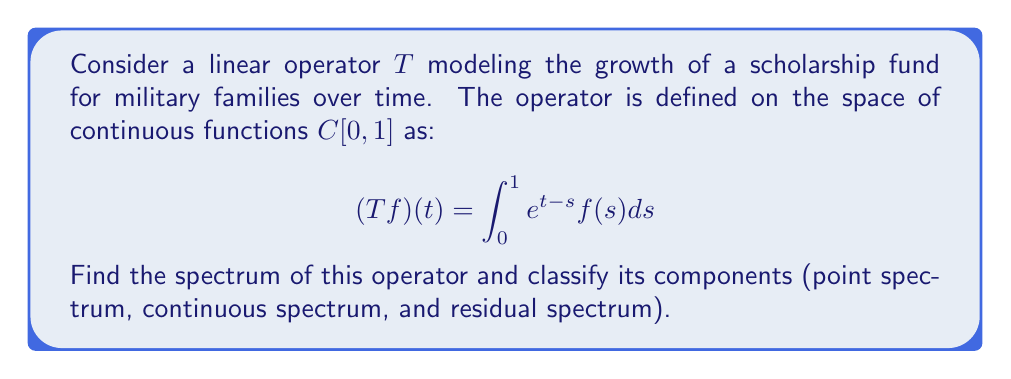Provide a solution to this math problem. 1) First, we need to find the resolvent set and the spectrum of $T$.

2) The resolvent operator is given by $R(\lambda,T) = (\lambda I - T)^{-1}$.

3) To find the spectrum, we need to solve the equation:

   $$(\lambda I - T)f = g$$

   This is equivalent to:

   $$\lambda f(t) - \int_0^1 e^{t-s}f(s)ds = g(t)$$

4) Differentiating both sides with respect to $t$:

   $$\lambda f'(t) - f(t) + \int_0^1 e^{t-s}f(s)ds = g'(t)$$

5) Subtracting the original equation from this:

   $$\lambda f'(t) - f(t) = g'(t) - g(t)$$

6) This is a first-order linear differential equation. Its general solution is:

   $$f(t) = Ce^{t/\lambda} + \frac{1}{\lambda}e^{t/\lambda}\int_0^t e^{-s/\lambda}g(s)ds$$

7) The constant $C$ can be determined from the original integral equation.

8) For this solution to exist and be unique for all $g \in C[0,1]$, we must have $\lambda \neq 0$.

9) When $\lambda = 0$, the equation becomes:

   $$-\int_0^1 e^{t-s}f(s)ds = g(t)$$

   This has a solution if and only if $g(1) = 0$.

10) Therefore, the spectrum of $T$ is $\{0\} \cup \{\lambda \in \mathbb{C} : |\lambda| \leq 1\}$.

11) Classification of the spectrum:
    - Point spectrum: $\emptyset$ (no eigenvalues)
    - Continuous spectrum: $\{\lambda \in \mathbb{C} : |\lambda| = 1\}$
    - Residual spectrum: $\{0\} \cup \{\lambda \in \mathbb{C} : |\lambda| < 1\}$
Answer: $\sigma(T) = \{0\} \cup \{\lambda \in \mathbb{C} : |\lambda| \leq 1\}$; $\sigma_p(T) = \emptyset$, $\sigma_c(T) = \{\lambda : |\lambda| = 1\}$, $\sigma_r(T) = \{0\} \cup \{\lambda : |\lambda| < 1\}$ 